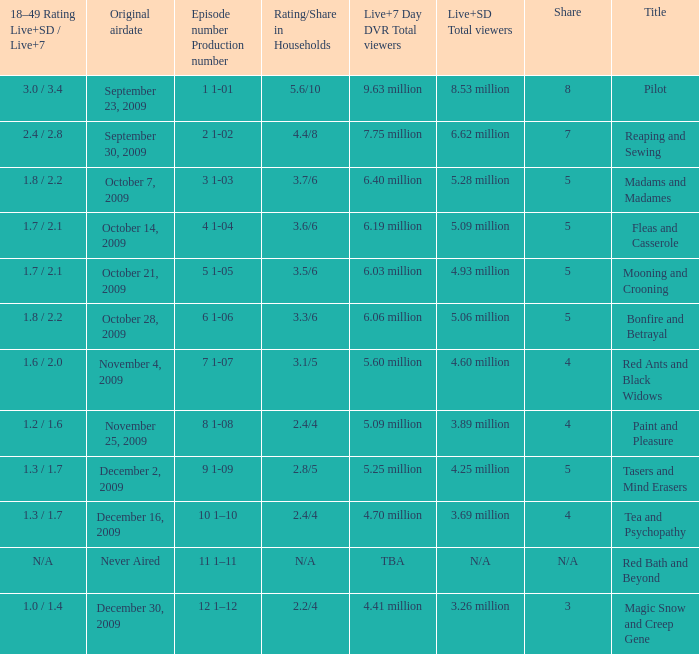What are the "18–49 Rating Live+SD" ratings and "Live+7" ratings, respectively, for the episode that originally aired on October 14, 2009? 1.7 / 2.1. 